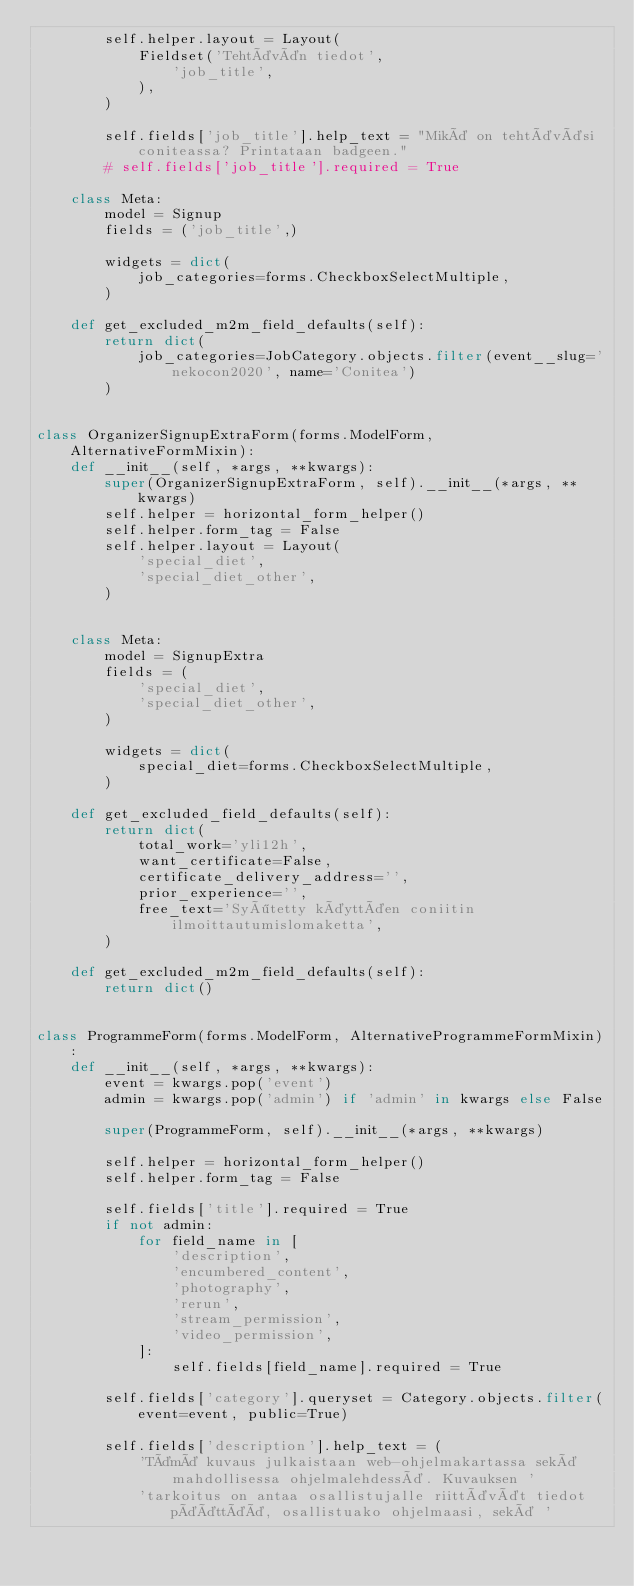Convert code to text. <code><loc_0><loc_0><loc_500><loc_500><_Python_>        self.helper.layout = Layout(
            Fieldset('Tehtävän tiedot',
                'job_title',
            ),
        )

        self.fields['job_title'].help_text = "Mikä on tehtäväsi coniteassa? Printataan badgeen."
        # self.fields['job_title'].required = True

    class Meta:
        model = Signup
        fields = ('job_title',)

        widgets = dict(
            job_categories=forms.CheckboxSelectMultiple,
        )

    def get_excluded_m2m_field_defaults(self):
        return dict(
            job_categories=JobCategory.objects.filter(event__slug='nekocon2020', name='Conitea')
        )


class OrganizerSignupExtraForm(forms.ModelForm, AlternativeFormMixin):
    def __init__(self, *args, **kwargs):
        super(OrganizerSignupExtraForm, self).__init__(*args, **kwargs)
        self.helper = horizontal_form_helper()
        self.helper.form_tag = False
        self.helper.layout = Layout(
            'special_diet',
            'special_diet_other',
        )


    class Meta:
        model = SignupExtra
        fields = (
            'special_diet',
            'special_diet_other',
        )

        widgets = dict(
            special_diet=forms.CheckboxSelectMultiple,
        )

    def get_excluded_field_defaults(self):
        return dict(
            total_work='yli12h',
            want_certificate=False,
            certificate_delivery_address='',
            prior_experience='',
            free_text='Syötetty käyttäen coniitin ilmoittautumislomaketta',
        )

    def get_excluded_m2m_field_defaults(self):
        return dict()


class ProgrammeForm(forms.ModelForm, AlternativeProgrammeFormMixin):
    def __init__(self, *args, **kwargs):
        event = kwargs.pop('event')
        admin = kwargs.pop('admin') if 'admin' in kwargs else False

        super(ProgrammeForm, self).__init__(*args, **kwargs)

        self.helper = horizontal_form_helper()
        self.helper.form_tag = False

        self.fields['title'].required = True
        if not admin:
            for field_name in [
                'description',
                'encumbered_content',
                'photography',
                'rerun',
                'stream_permission',
                'video_permission',
            ]:
                self.fields[field_name].required = True

        self.fields['category'].queryset = Category.objects.filter(event=event, public=True)

        self.fields['description'].help_text = (
            'Tämä kuvaus julkaistaan web-ohjelmakartassa sekä mahdollisessa ohjelmalehdessä. Kuvauksen '
            'tarkoitus on antaa osallistujalle riittävät tiedot päättää, osallistuako ohjelmaasi, sekä '</code> 